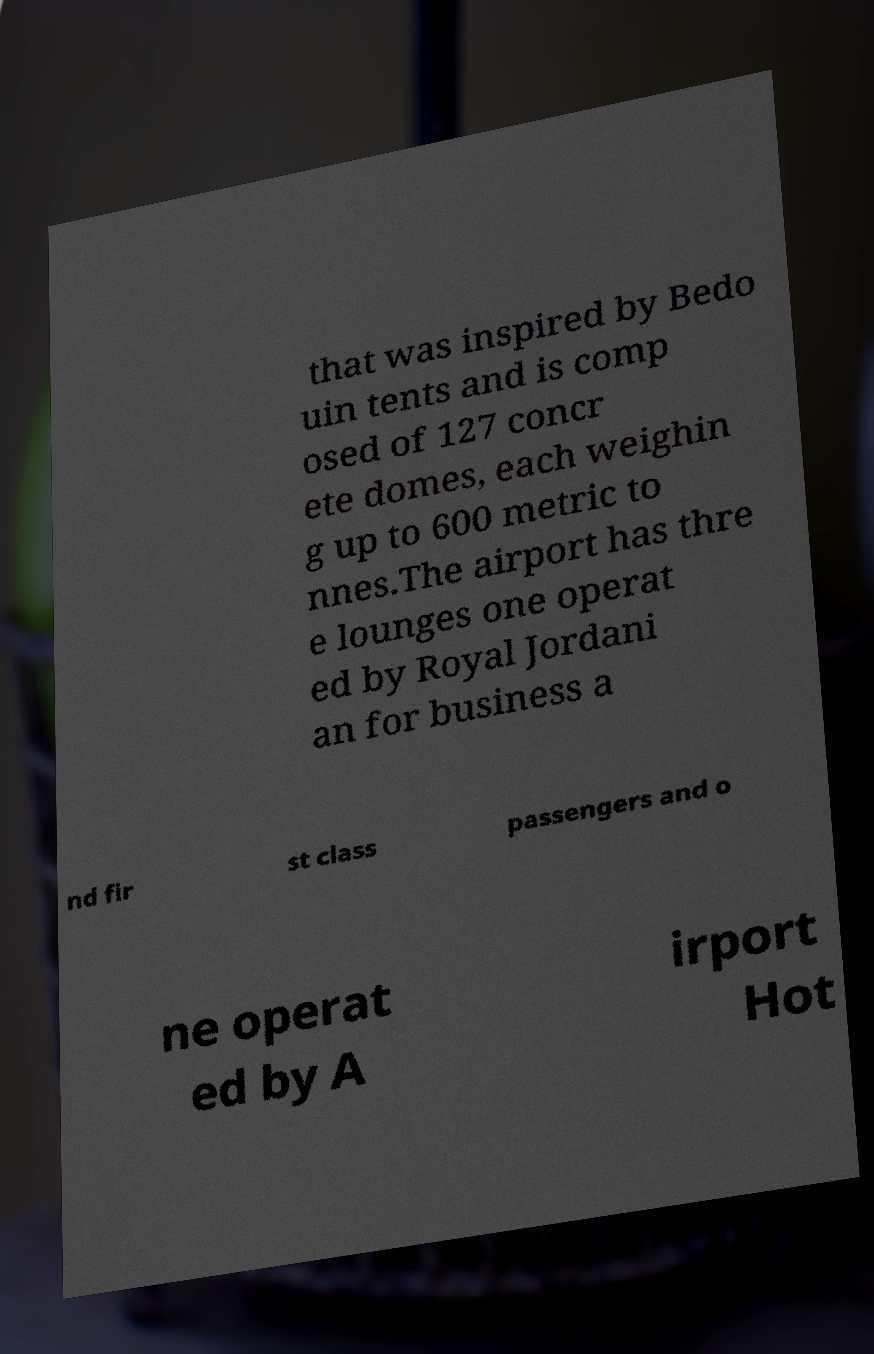For documentation purposes, I need the text within this image transcribed. Could you provide that? that was inspired by Bedo uin tents and is comp osed of 127 concr ete domes, each weighin g up to 600 metric to nnes.The airport has thre e lounges one operat ed by Royal Jordani an for business a nd fir st class passengers and o ne operat ed by A irport Hot 